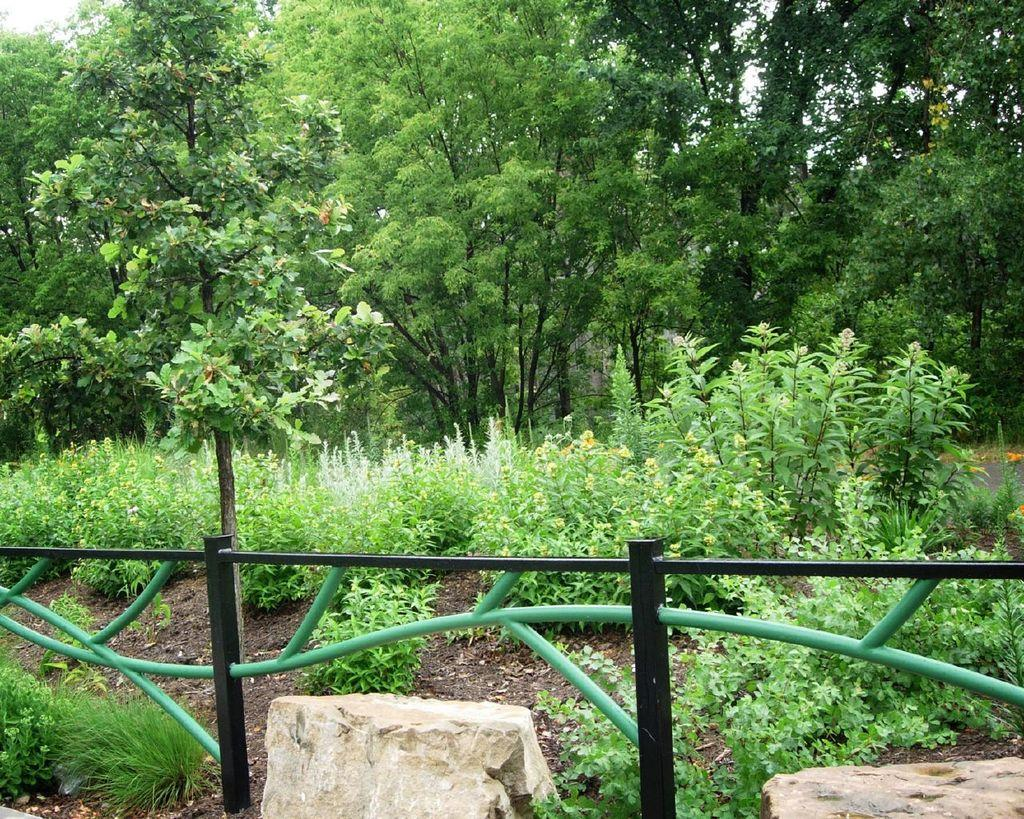What type of structure can be seen in the image? There is an iron railing in the image. How many stones are visible in the image? There are two stones in the image. What type of vegetation is present in the image? Grass and plants are visible in the image. What can be seen in the background of the image? There are trees and the sky visible in the background of the image. What type of rule is being enforced by the trees in the image? There is no rule being enforced by the trees in the image; they are simply part of the natural landscape. What type of skin condition can be seen on the plants in the image? There is no skin condition present on the plants in the image; they are healthy and green. 